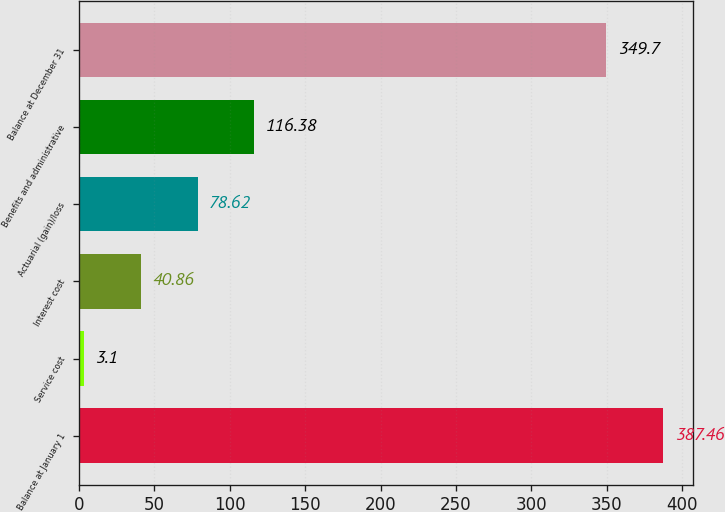Convert chart to OTSL. <chart><loc_0><loc_0><loc_500><loc_500><bar_chart><fcel>Balance at January 1<fcel>Service cost<fcel>Interest cost<fcel>Actuarial (gain)/loss<fcel>Benefits and administrative<fcel>Balance at December 31<nl><fcel>387.46<fcel>3.1<fcel>40.86<fcel>78.62<fcel>116.38<fcel>349.7<nl></chart> 